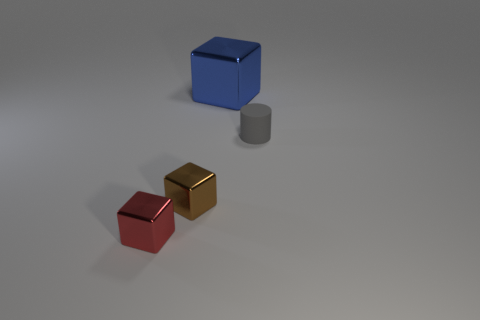Subtract 1 cubes. How many cubes are left? 2 Subtract all small cubes. How many cubes are left? 1 Add 3 blue things. How many objects exist? 7 Subtract 0 red spheres. How many objects are left? 4 Subtract all blocks. How many objects are left? 1 Subtract all small rubber cylinders. Subtract all brown metal cylinders. How many objects are left? 3 Add 2 blue metal blocks. How many blue metal blocks are left? 3 Add 4 gray matte cylinders. How many gray matte cylinders exist? 5 